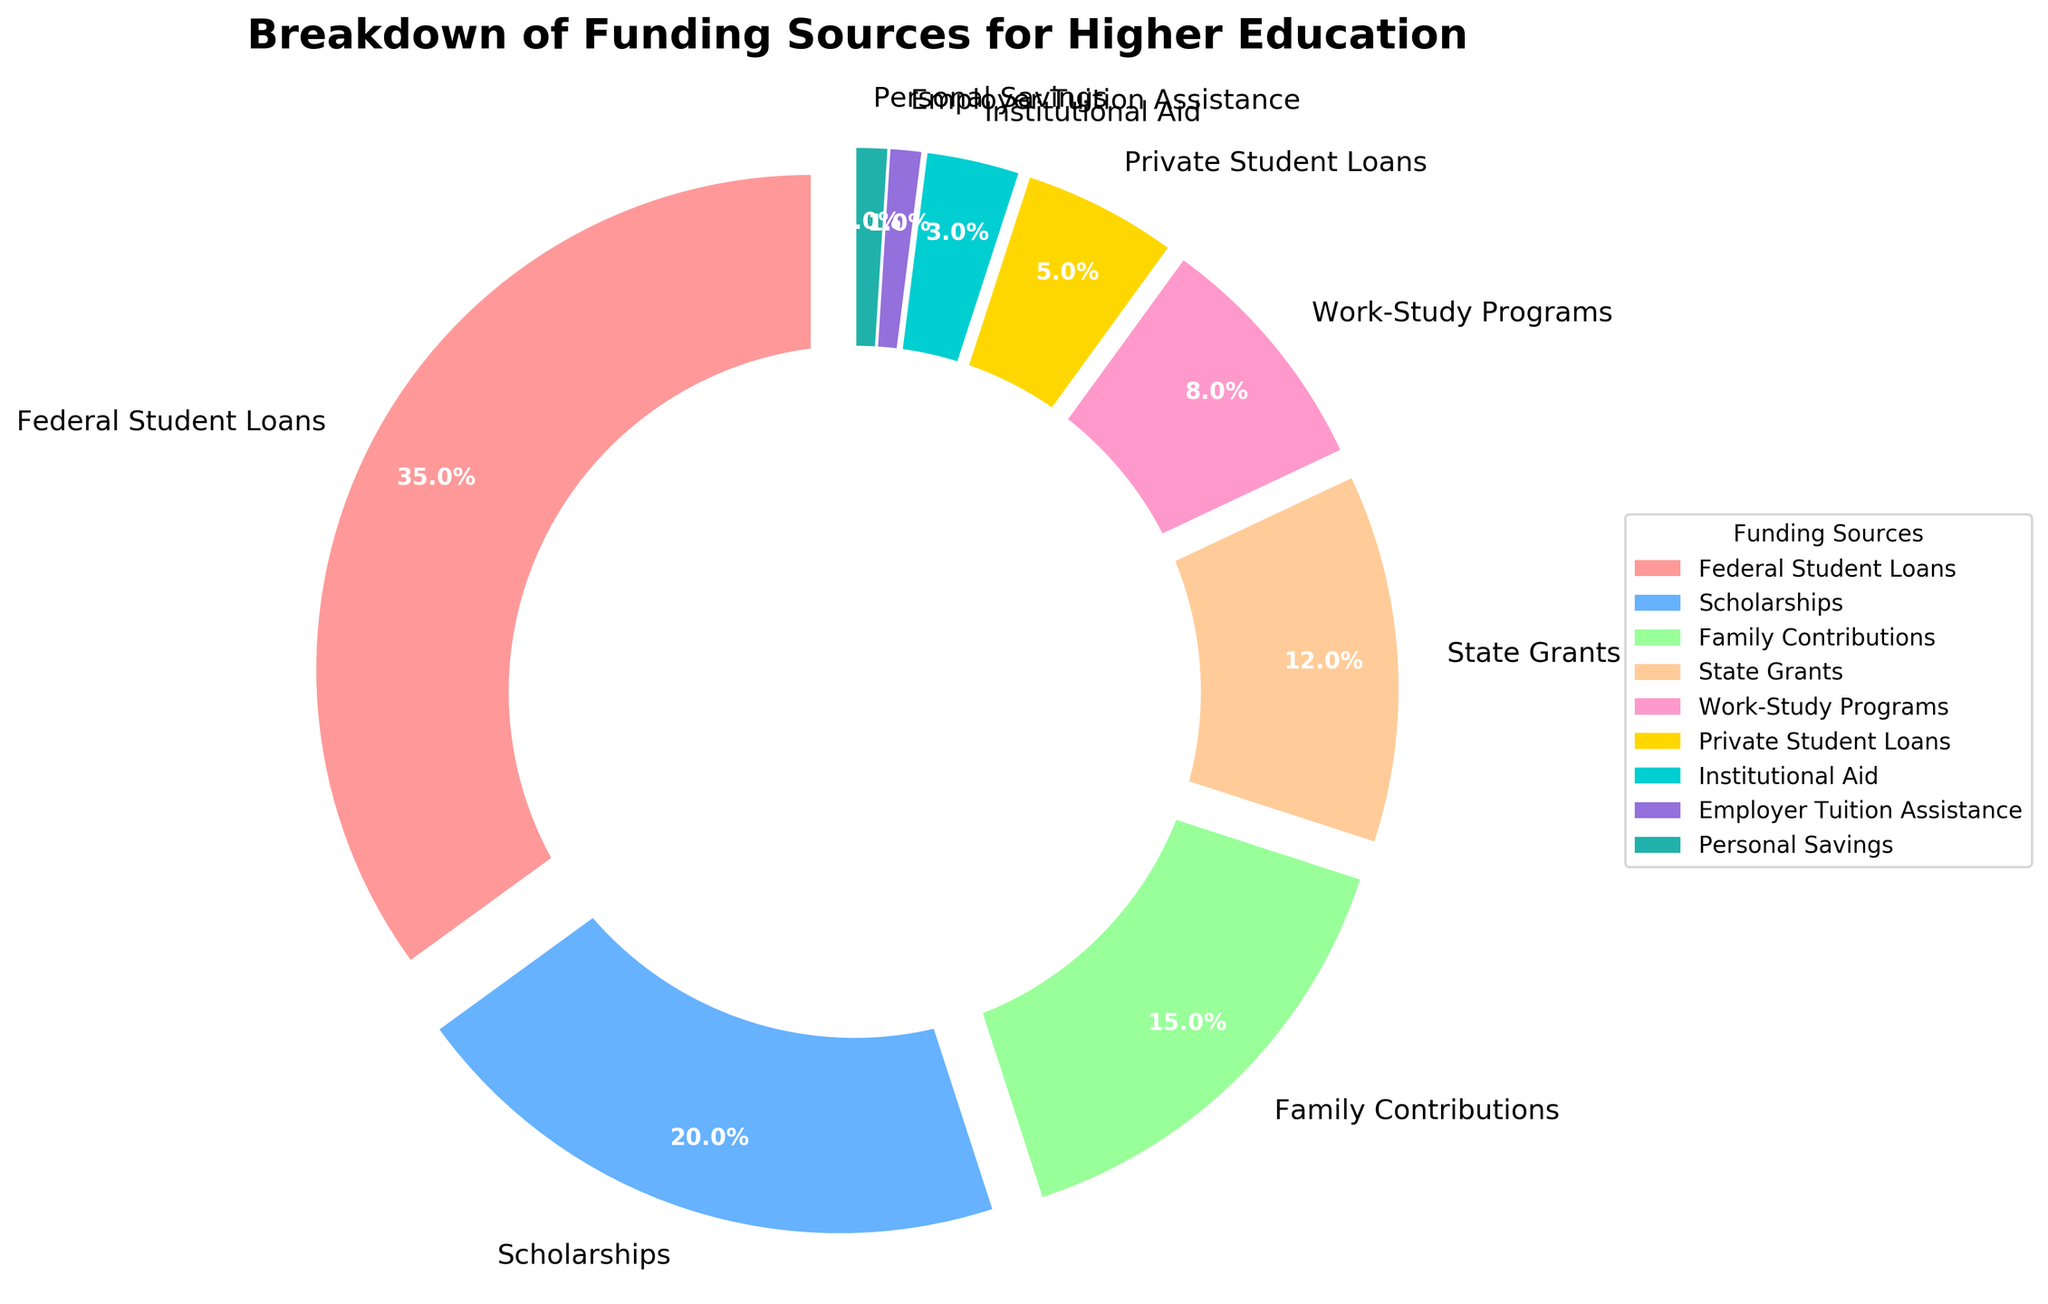What is the source that contributes the highest percentage to funding higher education? The largest wedge in the pie chart represents Federal Student Loans. This wedge is 35% of the pie, making it the highest percentage contributor.
Answer: Federal Student Loans How much funding percentage comes from scholarships and state grants combined? The wedges for Scholarships and State Grants are 20% and 12%, respectively. Combined, this is \( 20\% + 12\% = 32\% \).
Answer: 32% Which funding source contributes less, Private Student Loans or Work-Study Programs? The wedges representing Private Student Loans and Work-Study Programs are 5% and 8%, respectively. Since 5% is less than 8%, Private Student Loans contributes less.
Answer: Private Student Loans What portion of the funding is from Family Contributions and Personal Savings together? Family Contributions and Personal Savings are represented by wedges of 15% and 1% respectively. Added together, the percentage is \( 15\% + 1\% = 16\% \).
Answer: 16% Is the contribution from Institutional Aid greater than Employer Tuition Assistance? The wedges for Institutional Aid and Employer Tuition Assistance are 3% and 1%, respectively. Since 3% is greater than 1%, Institutional Aid contributes more.
Answer: Yes What is the total percentage of funding sources contributing less than 10% each? Work-Study Programs (8%), Private Student Loans (5%), Institutional Aid (3%), Employer Tuition Assistance (1%), and Personal Savings (1%) each contribute less than 10%. The combined contribution is \( 8\% + 5\% + 3\% + 1\% + 1\% = 18\% \).
Answer: 18% Compare the visual sizes of the wedges representing Family Contributions and State Grants. The wedge for Family Contributions is larger than the wedge for State Grants; Family Contributions is 15%, while State Grants is only 12%.
Answer: Family Contributions Which two sources have the same contribution percentages? The pie chart shows that Employer Tuition Assistance and Personal Savings both have wedges representing 1% of the total funding.
Answer: Employer Tuition Assistance and Personal Savings What is the second largest funding source? After Federal Student Loans (35%), the next largest wedge is Scholarships at 20%.
Answer: Scholarships If Federal Student Loans and Scholarships together make up a certain portion of the funding, what percentage is the rest? Federal Student Loans and Scholarships together make up \( 35\% + 20\% = 55\% \) of the funding. The rest would be \( 100\% - 55\% = 45\% \).
Answer: 45% 